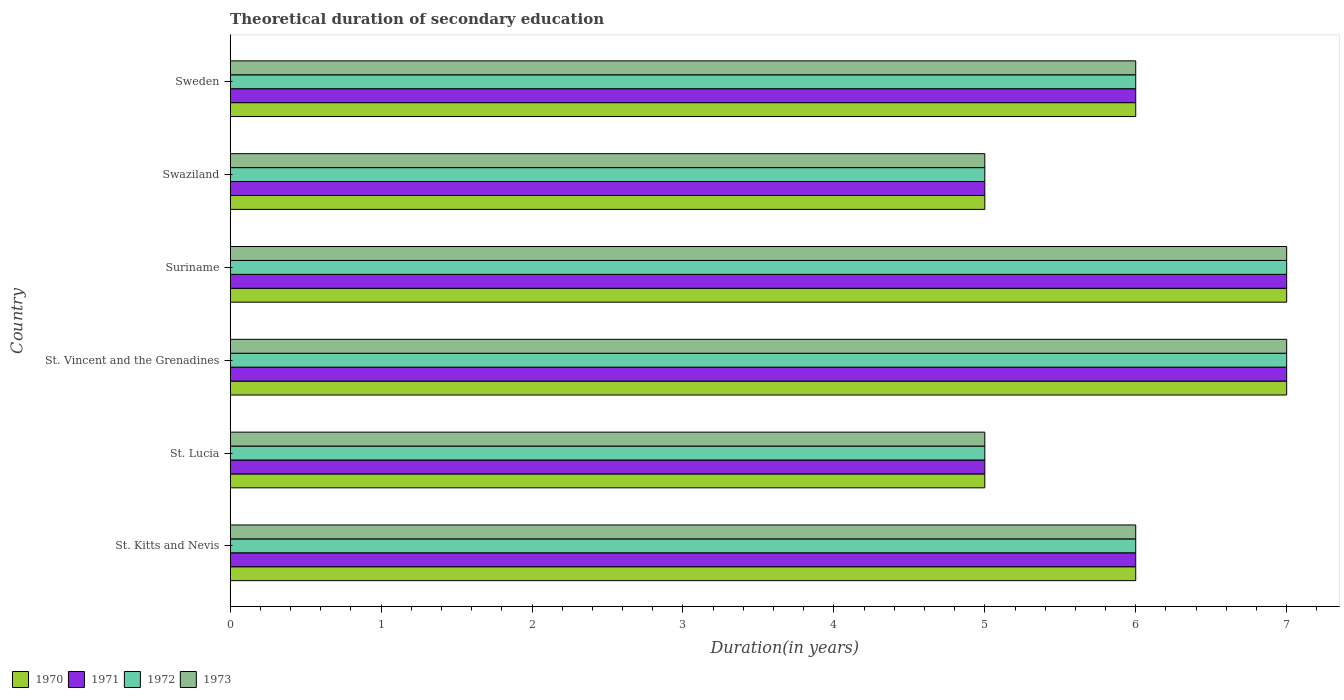How many different coloured bars are there?
Offer a very short reply. 4. Are the number of bars on each tick of the Y-axis equal?
Your response must be concise. Yes. How many bars are there on the 2nd tick from the top?
Offer a very short reply. 4. How many bars are there on the 1st tick from the bottom?
Make the answer very short. 4. What is the label of the 6th group of bars from the top?
Offer a very short reply. St. Kitts and Nevis. Across all countries, what is the maximum total theoretical duration of secondary education in 1971?
Offer a very short reply. 7. Across all countries, what is the minimum total theoretical duration of secondary education in 1973?
Your response must be concise. 5. In which country was the total theoretical duration of secondary education in 1973 maximum?
Your response must be concise. St. Vincent and the Grenadines. In which country was the total theoretical duration of secondary education in 1971 minimum?
Offer a terse response. St. Lucia. What is the total total theoretical duration of secondary education in 1970 in the graph?
Your answer should be very brief. 36. What is the difference between the total theoretical duration of secondary education in 1973 in St. Lucia and that in Suriname?
Your answer should be very brief. -2. What is the ratio of the total theoretical duration of secondary education in 1971 in St. Kitts and Nevis to that in Suriname?
Your answer should be compact. 0.86. Is the total theoretical duration of secondary education in 1971 in St. Lucia less than that in Sweden?
Offer a very short reply. Yes. What is the difference between the highest and the second highest total theoretical duration of secondary education in 1970?
Offer a very short reply. 0. In how many countries, is the total theoretical duration of secondary education in 1970 greater than the average total theoretical duration of secondary education in 1970 taken over all countries?
Your response must be concise. 2. Is it the case that in every country, the sum of the total theoretical duration of secondary education in 1972 and total theoretical duration of secondary education in 1971 is greater than the sum of total theoretical duration of secondary education in 1970 and total theoretical duration of secondary education in 1973?
Make the answer very short. No. What does the 1st bar from the bottom in Swaziland represents?
Your answer should be very brief. 1970. Is it the case that in every country, the sum of the total theoretical duration of secondary education in 1971 and total theoretical duration of secondary education in 1972 is greater than the total theoretical duration of secondary education in 1970?
Your answer should be very brief. Yes. How many bars are there?
Keep it short and to the point. 24. Are the values on the major ticks of X-axis written in scientific E-notation?
Your answer should be very brief. No. Does the graph contain any zero values?
Keep it short and to the point. No. Where does the legend appear in the graph?
Your response must be concise. Bottom left. How many legend labels are there?
Provide a short and direct response. 4. How are the legend labels stacked?
Keep it short and to the point. Horizontal. What is the title of the graph?
Give a very brief answer. Theoretical duration of secondary education. Does "1976" appear as one of the legend labels in the graph?
Offer a very short reply. No. What is the label or title of the X-axis?
Give a very brief answer. Duration(in years). What is the label or title of the Y-axis?
Ensure brevity in your answer.  Country. What is the Duration(in years) in 1970 in St. Kitts and Nevis?
Provide a short and direct response. 6. What is the Duration(in years) in 1970 in St. Lucia?
Your response must be concise. 5. What is the Duration(in years) of 1972 in St. Lucia?
Keep it short and to the point. 5. What is the Duration(in years) in 1970 in St. Vincent and the Grenadines?
Give a very brief answer. 7. What is the Duration(in years) of 1971 in St. Vincent and the Grenadines?
Give a very brief answer. 7. What is the Duration(in years) in 1973 in St. Vincent and the Grenadines?
Make the answer very short. 7. What is the Duration(in years) in 1970 in Suriname?
Offer a terse response. 7. What is the Duration(in years) of 1972 in Suriname?
Provide a succinct answer. 7. What is the Duration(in years) of 1973 in Suriname?
Make the answer very short. 7. What is the Duration(in years) of 1970 in Swaziland?
Your answer should be very brief. 5. What is the Duration(in years) of 1971 in Swaziland?
Offer a very short reply. 5. Across all countries, what is the maximum Duration(in years) of 1970?
Provide a short and direct response. 7. What is the total Duration(in years) in 1970 in the graph?
Your answer should be very brief. 36. What is the total Duration(in years) in 1971 in the graph?
Your answer should be very brief. 36. What is the total Duration(in years) of 1973 in the graph?
Offer a very short reply. 36. What is the difference between the Duration(in years) of 1971 in St. Kitts and Nevis and that in St. Lucia?
Give a very brief answer. 1. What is the difference between the Duration(in years) of 1972 in St. Kitts and Nevis and that in St. Lucia?
Offer a terse response. 1. What is the difference between the Duration(in years) in 1973 in St. Kitts and Nevis and that in St. Lucia?
Offer a very short reply. 1. What is the difference between the Duration(in years) in 1973 in St. Kitts and Nevis and that in St. Vincent and the Grenadines?
Your answer should be compact. -1. What is the difference between the Duration(in years) of 1972 in St. Kitts and Nevis and that in Suriname?
Offer a very short reply. -1. What is the difference between the Duration(in years) of 1973 in St. Kitts and Nevis and that in Suriname?
Ensure brevity in your answer.  -1. What is the difference between the Duration(in years) of 1970 in St. Kitts and Nevis and that in Swaziland?
Keep it short and to the point. 1. What is the difference between the Duration(in years) in 1971 in St. Kitts and Nevis and that in Swaziland?
Provide a succinct answer. 1. What is the difference between the Duration(in years) in 1970 in St. Kitts and Nevis and that in Sweden?
Provide a succinct answer. 0. What is the difference between the Duration(in years) of 1971 in St. Kitts and Nevis and that in Sweden?
Give a very brief answer. 0. What is the difference between the Duration(in years) of 1972 in St. Kitts and Nevis and that in Sweden?
Your response must be concise. 0. What is the difference between the Duration(in years) in 1973 in St. Kitts and Nevis and that in Sweden?
Keep it short and to the point. 0. What is the difference between the Duration(in years) in 1972 in St. Lucia and that in St. Vincent and the Grenadines?
Your response must be concise. -2. What is the difference between the Duration(in years) of 1970 in St. Lucia and that in Suriname?
Provide a short and direct response. -2. What is the difference between the Duration(in years) of 1971 in St. Lucia and that in Suriname?
Offer a very short reply. -2. What is the difference between the Duration(in years) of 1972 in St. Lucia and that in Suriname?
Your response must be concise. -2. What is the difference between the Duration(in years) in 1970 in St. Lucia and that in Swaziland?
Offer a very short reply. 0. What is the difference between the Duration(in years) of 1970 in St. Lucia and that in Sweden?
Provide a succinct answer. -1. What is the difference between the Duration(in years) in 1973 in St. Lucia and that in Sweden?
Provide a succinct answer. -1. What is the difference between the Duration(in years) in 1971 in St. Vincent and the Grenadines and that in Suriname?
Provide a short and direct response. 0. What is the difference between the Duration(in years) of 1970 in St. Vincent and the Grenadines and that in Swaziland?
Make the answer very short. 2. What is the difference between the Duration(in years) in 1971 in St. Vincent and the Grenadines and that in Swaziland?
Provide a short and direct response. 2. What is the difference between the Duration(in years) in 1972 in St. Vincent and the Grenadines and that in Swaziland?
Keep it short and to the point. 2. What is the difference between the Duration(in years) in 1970 in St. Vincent and the Grenadines and that in Sweden?
Provide a succinct answer. 1. What is the difference between the Duration(in years) in 1971 in St. Vincent and the Grenadines and that in Sweden?
Your answer should be very brief. 1. What is the difference between the Duration(in years) of 1972 in St. Vincent and the Grenadines and that in Sweden?
Provide a short and direct response. 1. What is the difference between the Duration(in years) of 1973 in St. Vincent and the Grenadines and that in Sweden?
Make the answer very short. 1. What is the difference between the Duration(in years) in 1972 in Suriname and that in Swaziland?
Give a very brief answer. 2. What is the difference between the Duration(in years) of 1970 in Suriname and that in Sweden?
Make the answer very short. 1. What is the difference between the Duration(in years) of 1971 in Suriname and that in Sweden?
Your answer should be compact. 1. What is the difference between the Duration(in years) in 1971 in St. Kitts and Nevis and the Duration(in years) in 1973 in St. Lucia?
Offer a very short reply. 1. What is the difference between the Duration(in years) of 1970 in St. Kitts and Nevis and the Duration(in years) of 1973 in St. Vincent and the Grenadines?
Give a very brief answer. -1. What is the difference between the Duration(in years) of 1971 in St. Kitts and Nevis and the Duration(in years) of 1973 in St. Vincent and the Grenadines?
Your response must be concise. -1. What is the difference between the Duration(in years) in 1970 in St. Kitts and Nevis and the Duration(in years) in 1971 in Suriname?
Your response must be concise. -1. What is the difference between the Duration(in years) in 1970 in St. Kitts and Nevis and the Duration(in years) in 1973 in Suriname?
Make the answer very short. -1. What is the difference between the Duration(in years) in 1971 in St. Kitts and Nevis and the Duration(in years) in 1973 in Suriname?
Offer a terse response. -1. What is the difference between the Duration(in years) in 1972 in St. Kitts and Nevis and the Duration(in years) in 1973 in Suriname?
Your answer should be compact. -1. What is the difference between the Duration(in years) in 1970 in St. Kitts and Nevis and the Duration(in years) in 1972 in Sweden?
Your response must be concise. 0. What is the difference between the Duration(in years) in 1971 in St. Kitts and Nevis and the Duration(in years) in 1973 in Sweden?
Your answer should be very brief. 0. What is the difference between the Duration(in years) in 1972 in St. Kitts and Nevis and the Duration(in years) in 1973 in Sweden?
Your response must be concise. 0. What is the difference between the Duration(in years) of 1970 in St. Lucia and the Duration(in years) of 1971 in St. Vincent and the Grenadines?
Provide a short and direct response. -2. What is the difference between the Duration(in years) of 1972 in St. Lucia and the Duration(in years) of 1973 in St. Vincent and the Grenadines?
Provide a succinct answer. -2. What is the difference between the Duration(in years) in 1970 in St. Lucia and the Duration(in years) in 1971 in Suriname?
Your answer should be compact. -2. What is the difference between the Duration(in years) in 1970 in St. Lucia and the Duration(in years) in 1973 in Suriname?
Provide a succinct answer. -2. What is the difference between the Duration(in years) in 1971 in St. Lucia and the Duration(in years) in 1972 in Suriname?
Ensure brevity in your answer.  -2. What is the difference between the Duration(in years) in 1970 in St. Lucia and the Duration(in years) in 1971 in Swaziland?
Your answer should be compact. 0. What is the difference between the Duration(in years) of 1970 in St. Lucia and the Duration(in years) of 1972 in Swaziland?
Make the answer very short. 0. What is the difference between the Duration(in years) of 1970 in St. Lucia and the Duration(in years) of 1973 in Swaziland?
Offer a terse response. 0. What is the difference between the Duration(in years) in 1971 in St. Lucia and the Duration(in years) in 1972 in Swaziland?
Give a very brief answer. 0. What is the difference between the Duration(in years) of 1972 in St. Lucia and the Duration(in years) of 1973 in Swaziland?
Give a very brief answer. 0. What is the difference between the Duration(in years) of 1971 in St. Lucia and the Duration(in years) of 1972 in Sweden?
Ensure brevity in your answer.  -1. What is the difference between the Duration(in years) in 1972 in St. Lucia and the Duration(in years) in 1973 in Sweden?
Offer a very short reply. -1. What is the difference between the Duration(in years) in 1970 in St. Vincent and the Grenadines and the Duration(in years) in 1973 in Suriname?
Your answer should be compact. 0. What is the difference between the Duration(in years) in 1971 in St. Vincent and the Grenadines and the Duration(in years) in 1972 in Suriname?
Offer a terse response. 0. What is the difference between the Duration(in years) in 1971 in St. Vincent and the Grenadines and the Duration(in years) in 1973 in Suriname?
Ensure brevity in your answer.  0. What is the difference between the Duration(in years) of 1972 in St. Vincent and the Grenadines and the Duration(in years) of 1973 in Swaziland?
Your response must be concise. 2. What is the difference between the Duration(in years) of 1970 in St. Vincent and the Grenadines and the Duration(in years) of 1971 in Sweden?
Ensure brevity in your answer.  1. What is the difference between the Duration(in years) in 1971 in St. Vincent and the Grenadines and the Duration(in years) in 1972 in Sweden?
Keep it short and to the point. 1. What is the difference between the Duration(in years) of 1971 in St. Vincent and the Grenadines and the Duration(in years) of 1973 in Sweden?
Provide a succinct answer. 1. What is the difference between the Duration(in years) of 1971 in Suriname and the Duration(in years) of 1972 in Swaziland?
Your answer should be very brief. 2. What is the difference between the Duration(in years) in 1972 in Suriname and the Duration(in years) in 1973 in Swaziland?
Offer a terse response. 2. What is the difference between the Duration(in years) of 1970 in Suriname and the Duration(in years) of 1971 in Sweden?
Your answer should be very brief. 1. What is the difference between the Duration(in years) of 1970 in Suriname and the Duration(in years) of 1972 in Sweden?
Your answer should be very brief. 1. What is the difference between the Duration(in years) of 1970 in Suriname and the Duration(in years) of 1973 in Sweden?
Your answer should be very brief. 1. What is the difference between the Duration(in years) in 1970 in Swaziland and the Duration(in years) in 1971 in Sweden?
Provide a short and direct response. -1. What is the difference between the Duration(in years) in 1970 in Swaziland and the Duration(in years) in 1972 in Sweden?
Ensure brevity in your answer.  -1. What is the difference between the Duration(in years) in 1970 in Swaziland and the Duration(in years) in 1973 in Sweden?
Offer a very short reply. -1. What is the difference between the Duration(in years) in 1972 in Swaziland and the Duration(in years) in 1973 in Sweden?
Offer a terse response. -1. What is the average Duration(in years) of 1972 per country?
Provide a short and direct response. 6. What is the difference between the Duration(in years) in 1970 and Duration(in years) in 1971 in St. Kitts and Nevis?
Make the answer very short. 0. What is the difference between the Duration(in years) in 1970 and Duration(in years) in 1973 in St. Kitts and Nevis?
Keep it short and to the point. 0. What is the difference between the Duration(in years) in 1971 and Duration(in years) in 1973 in St. Kitts and Nevis?
Keep it short and to the point. 0. What is the difference between the Duration(in years) in 1970 and Duration(in years) in 1973 in St. Lucia?
Keep it short and to the point. 0. What is the difference between the Duration(in years) in 1972 and Duration(in years) in 1973 in St. Lucia?
Provide a succinct answer. 0. What is the difference between the Duration(in years) of 1970 and Duration(in years) of 1971 in Suriname?
Your answer should be compact. 0. What is the difference between the Duration(in years) in 1970 and Duration(in years) in 1972 in Suriname?
Your response must be concise. 0. What is the difference between the Duration(in years) of 1970 and Duration(in years) of 1973 in Suriname?
Provide a succinct answer. 0. What is the difference between the Duration(in years) of 1970 and Duration(in years) of 1972 in Swaziland?
Keep it short and to the point. 0. What is the difference between the Duration(in years) of 1970 and Duration(in years) of 1973 in Swaziland?
Your answer should be very brief. 0. What is the difference between the Duration(in years) in 1971 and Duration(in years) in 1972 in Swaziland?
Offer a very short reply. 0. What is the difference between the Duration(in years) of 1971 and Duration(in years) of 1973 in Swaziland?
Make the answer very short. 0. What is the difference between the Duration(in years) in 1972 and Duration(in years) in 1973 in Swaziland?
Keep it short and to the point. 0. What is the difference between the Duration(in years) in 1970 and Duration(in years) in 1972 in Sweden?
Your response must be concise. 0. What is the difference between the Duration(in years) in 1970 and Duration(in years) in 1973 in Sweden?
Offer a very short reply. 0. What is the difference between the Duration(in years) of 1971 and Duration(in years) of 1972 in Sweden?
Provide a succinct answer. 0. What is the ratio of the Duration(in years) of 1971 in St. Kitts and Nevis to that in St. Lucia?
Your response must be concise. 1.2. What is the ratio of the Duration(in years) of 1972 in St. Kitts and Nevis to that in St. Lucia?
Keep it short and to the point. 1.2. What is the ratio of the Duration(in years) in 1973 in St. Kitts and Nevis to that in St. Lucia?
Make the answer very short. 1.2. What is the ratio of the Duration(in years) of 1970 in St. Kitts and Nevis to that in St. Vincent and the Grenadines?
Your answer should be compact. 0.86. What is the ratio of the Duration(in years) of 1972 in St. Kitts and Nevis to that in St. Vincent and the Grenadines?
Your answer should be very brief. 0.86. What is the ratio of the Duration(in years) of 1971 in St. Kitts and Nevis to that in Suriname?
Make the answer very short. 0.86. What is the ratio of the Duration(in years) of 1972 in St. Kitts and Nevis to that in Swaziland?
Make the answer very short. 1.2. What is the ratio of the Duration(in years) in 1970 in St. Kitts and Nevis to that in Sweden?
Your response must be concise. 1. What is the ratio of the Duration(in years) in 1971 in St. Kitts and Nevis to that in Sweden?
Your answer should be very brief. 1. What is the ratio of the Duration(in years) in 1973 in St. Kitts and Nevis to that in Sweden?
Make the answer very short. 1. What is the ratio of the Duration(in years) in 1971 in St. Lucia to that in St. Vincent and the Grenadines?
Keep it short and to the point. 0.71. What is the ratio of the Duration(in years) in 1972 in St. Lucia to that in St. Vincent and the Grenadines?
Provide a short and direct response. 0.71. What is the ratio of the Duration(in years) in 1973 in St. Lucia to that in Suriname?
Your answer should be very brief. 0.71. What is the ratio of the Duration(in years) of 1970 in St. Lucia to that in Swaziland?
Offer a terse response. 1. What is the ratio of the Duration(in years) in 1971 in St. Lucia to that in Swaziland?
Ensure brevity in your answer.  1. What is the ratio of the Duration(in years) of 1970 in St. Vincent and the Grenadines to that in Suriname?
Provide a short and direct response. 1. What is the ratio of the Duration(in years) in 1972 in St. Vincent and the Grenadines to that in Suriname?
Keep it short and to the point. 1. What is the ratio of the Duration(in years) of 1970 in St. Vincent and the Grenadines to that in Swaziland?
Offer a very short reply. 1.4. What is the ratio of the Duration(in years) in 1973 in St. Vincent and the Grenadines to that in Sweden?
Your answer should be very brief. 1.17. What is the ratio of the Duration(in years) in 1972 in Suriname to that in Swaziland?
Give a very brief answer. 1.4. What is the ratio of the Duration(in years) of 1970 in Suriname to that in Sweden?
Your answer should be very brief. 1.17. What is the ratio of the Duration(in years) of 1971 in Suriname to that in Sweden?
Give a very brief answer. 1.17. What is the ratio of the Duration(in years) of 1972 in Suriname to that in Sweden?
Provide a succinct answer. 1.17. What is the ratio of the Duration(in years) of 1973 in Suriname to that in Sweden?
Your response must be concise. 1.17. What is the ratio of the Duration(in years) of 1970 in Swaziland to that in Sweden?
Provide a succinct answer. 0.83. What is the ratio of the Duration(in years) of 1971 in Swaziland to that in Sweden?
Provide a succinct answer. 0.83. What is the ratio of the Duration(in years) of 1973 in Swaziland to that in Sweden?
Your answer should be very brief. 0.83. What is the difference between the highest and the second highest Duration(in years) in 1970?
Give a very brief answer. 0. What is the difference between the highest and the second highest Duration(in years) of 1971?
Offer a very short reply. 0. What is the difference between the highest and the lowest Duration(in years) of 1970?
Your answer should be compact. 2. What is the difference between the highest and the lowest Duration(in years) in 1972?
Your answer should be very brief. 2. What is the difference between the highest and the lowest Duration(in years) of 1973?
Provide a succinct answer. 2. 